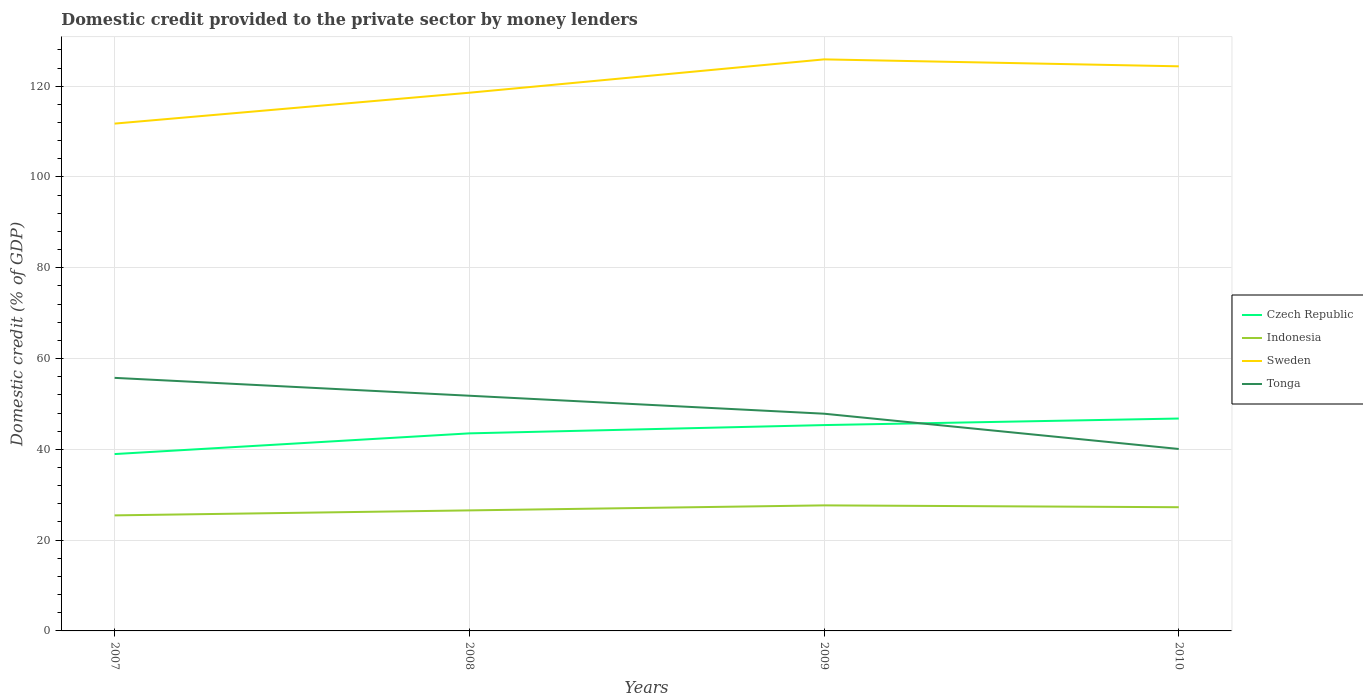How many different coloured lines are there?
Make the answer very short. 4. Does the line corresponding to Indonesia intersect with the line corresponding to Tonga?
Make the answer very short. No. Is the number of lines equal to the number of legend labels?
Keep it short and to the point. Yes. Across all years, what is the maximum domestic credit provided to the private sector by money lenders in Indonesia?
Your answer should be compact. 25.46. In which year was the domestic credit provided to the private sector by money lenders in Indonesia maximum?
Your answer should be very brief. 2007. What is the total domestic credit provided to the private sector by money lenders in Czech Republic in the graph?
Offer a very short reply. -6.39. What is the difference between the highest and the second highest domestic credit provided to the private sector by money lenders in Tonga?
Your response must be concise. 15.67. Is the domestic credit provided to the private sector by money lenders in Tonga strictly greater than the domestic credit provided to the private sector by money lenders in Sweden over the years?
Offer a very short reply. Yes. Where does the legend appear in the graph?
Make the answer very short. Center right. How are the legend labels stacked?
Provide a short and direct response. Vertical. What is the title of the graph?
Your answer should be very brief. Domestic credit provided to the private sector by money lenders. What is the label or title of the X-axis?
Offer a terse response. Years. What is the label or title of the Y-axis?
Offer a terse response. Domestic credit (% of GDP). What is the Domestic credit (% of GDP) of Czech Republic in 2007?
Offer a terse response. 38.96. What is the Domestic credit (% of GDP) in Indonesia in 2007?
Your answer should be compact. 25.46. What is the Domestic credit (% of GDP) of Sweden in 2007?
Provide a succinct answer. 111.76. What is the Domestic credit (% of GDP) of Tonga in 2007?
Provide a succinct answer. 55.75. What is the Domestic credit (% of GDP) of Czech Republic in 2008?
Ensure brevity in your answer.  43.52. What is the Domestic credit (% of GDP) of Indonesia in 2008?
Make the answer very short. 26.55. What is the Domestic credit (% of GDP) of Sweden in 2008?
Your response must be concise. 118.57. What is the Domestic credit (% of GDP) of Tonga in 2008?
Give a very brief answer. 51.81. What is the Domestic credit (% of GDP) in Czech Republic in 2009?
Make the answer very short. 45.35. What is the Domestic credit (% of GDP) of Indonesia in 2009?
Offer a very short reply. 27.66. What is the Domestic credit (% of GDP) in Sweden in 2009?
Provide a succinct answer. 125.91. What is the Domestic credit (% of GDP) in Tonga in 2009?
Your answer should be very brief. 47.85. What is the Domestic credit (% of GDP) in Czech Republic in 2010?
Your answer should be very brief. 46.79. What is the Domestic credit (% of GDP) of Indonesia in 2010?
Give a very brief answer. 27.25. What is the Domestic credit (% of GDP) in Sweden in 2010?
Keep it short and to the point. 124.38. What is the Domestic credit (% of GDP) in Tonga in 2010?
Keep it short and to the point. 40.08. Across all years, what is the maximum Domestic credit (% of GDP) of Czech Republic?
Your answer should be very brief. 46.79. Across all years, what is the maximum Domestic credit (% of GDP) in Indonesia?
Your answer should be compact. 27.66. Across all years, what is the maximum Domestic credit (% of GDP) of Sweden?
Give a very brief answer. 125.91. Across all years, what is the maximum Domestic credit (% of GDP) in Tonga?
Provide a short and direct response. 55.75. Across all years, what is the minimum Domestic credit (% of GDP) of Czech Republic?
Your response must be concise. 38.96. Across all years, what is the minimum Domestic credit (% of GDP) in Indonesia?
Your answer should be compact. 25.46. Across all years, what is the minimum Domestic credit (% of GDP) in Sweden?
Keep it short and to the point. 111.76. Across all years, what is the minimum Domestic credit (% of GDP) in Tonga?
Offer a terse response. 40.08. What is the total Domestic credit (% of GDP) in Czech Republic in the graph?
Give a very brief answer. 174.62. What is the total Domestic credit (% of GDP) in Indonesia in the graph?
Offer a terse response. 106.92. What is the total Domestic credit (% of GDP) in Sweden in the graph?
Ensure brevity in your answer.  480.62. What is the total Domestic credit (% of GDP) in Tonga in the graph?
Keep it short and to the point. 195.5. What is the difference between the Domestic credit (% of GDP) of Czech Republic in 2007 and that in 2008?
Give a very brief answer. -4.56. What is the difference between the Domestic credit (% of GDP) of Indonesia in 2007 and that in 2008?
Offer a very short reply. -1.1. What is the difference between the Domestic credit (% of GDP) in Sweden in 2007 and that in 2008?
Give a very brief answer. -6.81. What is the difference between the Domestic credit (% of GDP) in Tonga in 2007 and that in 2008?
Ensure brevity in your answer.  3.94. What is the difference between the Domestic credit (% of GDP) of Czech Republic in 2007 and that in 2009?
Offer a very short reply. -6.39. What is the difference between the Domestic credit (% of GDP) in Indonesia in 2007 and that in 2009?
Ensure brevity in your answer.  -2.2. What is the difference between the Domestic credit (% of GDP) in Sweden in 2007 and that in 2009?
Keep it short and to the point. -14.15. What is the difference between the Domestic credit (% of GDP) of Tonga in 2007 and that in 2009?
Ensure brevity in your answer.  7.9. What is the difference between the Domestic credit (% of GDP) of Czech Republic in 2007 and that in 2010?
Make the answer very short. -7.83. What is the difference between the Domestic credit (% of GDP) in Indonesia in 2007 and that in 2010?
Your response must be concise. -1.8. What is the difference between the Domestic credit (% of GDP) in Sweden in 2007 and that in 2010?
Your answer should be compact. -12.62. What is the difference between the Domestic credit (% of GDP) of Tonga in 2007 and that in 2010?
Make the answer very short. 15.67. What is the difference between the Domestic credit (% of GDP) of Czech Republic in 2008 and that in 2009?
Give a very brief answer. -1.83. What is the difference between the Domestic credit (% of GDP) of Indonesia in 2008 and that in 2009?
Provide a succinct answer. -1.11. What is the difference between the Domestic credit (% of GDP) in Sweden in 2008 and that in 2009?
Your answer should be very brief. -7.35. What is the difference between the Domestic credit (% of GDP) of Tonga in 2008 and that in 2009?
Your answer should be compact. 3.96. What is the difference between the Domestic credit (% of GDP) in Czech Republic in 2008 and that in 2010?
Make the answer very short. -3.27. What is the difference between the Domestic credit (% of GDP) in Indonesia in 2008 and that in 2010?
Your answer should be compact. -0.7. What is the difference between the Domestic credit (% of GDP) in Sweden in 2008 and that in 2010?
Ensure brevity in your answer.  -5.82. What is the difference between the Domestic credit (% of GDP) of Tonga in 2008 and that in 2010?
Your answer should be compact. 11.73. What is the difference between the Domestic credit (% of GDP) in Czech Republic in 2009 and that in 2010?
Make the answer very short. -1.44. What is the difference between the Domestic credit (% of GDP) of Indonesia in 2009 and that in 2010?
Keep it short and to the point. 0.41. What is the difference between the Domestic credit (% of GDP) of Sweden in 2009 and that in 2010?
Your answer should be compact. 1.53. What is the difference between the Domestic credit (% of GDP) in Tonga in 2009 and that in 2010?
Provide a succinct answer. 7.77. What is the difference between the Domestic credit (% of GDP) in Czech Republic in 2007 and the Domestic credit (% of GDP) in Indonesia in 2008?
Keep it short and to the point. 12.41. What is the difference between the Domestic credit (% of GDP) in Czech Republic in 2007 and the Domestic credit (% of GDP) in Sweden in 2008?
Offer a very short reply. -79.6. What is the difference between the Domestic credit (% of GDP) of Czech Republic in 2007 and the Domestic credit (% of GDP) of Tonga in 2008?
Your answer should be compact. -12.85. What is the difference between the Domestic credit (% of GDP) of Indonesia in 2007 and the Domestic credit (% of GDP) of Sweden in 2008?
Your response must be concise. -93.11. What is the difference between the Domestic credit (% of GDP) of Indonesia in 2007 and the Domestic credit (% of GDP) of Tonga in 2008?
Ensure brevity in your answer.  -26.36. What is the difference between the Domestic credit (% of GDP) of Sweden in 2007 and the Domestic credit (% of GDP) of Tonga in 2008?
Give a very brief answer. 59.95. What is the difference between the Domestic credit (% of GDP) of Czech Republic in 2007 and the Domestic credit (% of GDP) of Indonesia in 2009?
Give a very brief answer. 11.3. What is the difference between the Domestic credit (% of GDP) of Czech Republic in 2007 and the Domestic credit (% of GDP) of Sweden in 2009?
Provide a succinct answer. -86.95. What is the difference between the Domestic credit (% of GDP) in Czech Republic in 2007 and the Domestic credit (% of GDP) in Tonga in 2009?
Ensure brevity in your answer.  -8.89. What is the difference between the Domestic credit (% of GDP) in Indonesia in 2007 and the Domestic credit (% of GDP) in Sweden in 2009?
Your response must be concise. -100.46. What is the difference between the Domestic credit (% of GDP) of Indonesia in 2007 and the Domestic credit (% of GDP) of Tonga in 2009?
Ensure brevity in your answer.  -22.4. What is the difference between the Domestic credit (% of GDP) in Sweden in 2007 and the Domestic credit (% of GDP) in Tonga in 2009?
Provide a short and direct response. 63.91. What is the difference between the Domestic credit (% of GDP) of Czech Republic in 2007 and the Domestic credit (% of GDP) of Indonesia in 2010?
Provide a short and direct response. 11.71. What is the difference between the Domestic credit (% of GDP) of Czech Republic in 2007 and the Domestic credit (% of GDP) of Sweden in 2010?
Give a very brief answer. -85.42. What is the difference between the Domestic credit (% of GDP) in Czech Republic in 2007 and the Domestic credit (% of GDP) in Tonga in 2010?
Offer a very short reply. -1.12. What is the difference between the Domestic credit (% of GDP) in Indonesia in 2007 and the Domestic credit (% of GDP) in Sweden in 2010?
Your answer should be very brief. -98.93. What is the difference between the Domestic credit (% of GDP) of Indonesia in 2007 and the Domestic credit (% of GDP) of Tonga in 2010?
Ensure brevity in your answer.  -14.63. What is the difference between the Domestic credit (% of GDP) in Sweden in 2007 and the Domestic credit (% of GDP) in Tonga in 2010?
Your response must be concise. 71.68. What is the difference between the Domestic credit (% of GDP) of Czech Republic in 2008 and the Domestic credit (% of GDP) of Indonesia in 2009?
Your response must be concise. 15.86. What is the difference between the Domestic credit (% of GDP) of Czech Republic in 2008 and the Domestic credit (% of GDP) of Sweden in 2009?
Keep it short and to the point. -82.39. What is the difference between the Domestic credit (% of GDP) in Czech Republic in 2008 and the Domestic credit (% of GDP) in Tonga in 2009?
Ensure brevity in your answer.  -4.33. What is the difference between the Domestic credit (% of GDP) of Indonesia in 2008 and the Domestic credit (% of GDP) of Sweden in 2009?
Keep it short and to the point. -99.36. What is the difference between the Domestic credit (% of GDP) in Indonesia in 2008 and the Domestic credit (% of GDP) in Tonga in 2009?
Offer a very short reply. -21.3. What is the difference between the Domestic credit (% of GDP) in Sweden in 2008 and the Domestic credit (% of GDP) in Tonga in 2009?
Offer a very short reply. 70.71. What is the difference between the Domestic credit (% of GDP) in Czech Republic in 2008 and the Domestic credit (% of GDP) in Indonesia in 2010?
Make the answer very short. 16.27. What is the difference between the Domestic credit (% of GDP) of Czech Republic in 2008 and the Domestic credit (% of GDP) of Sweden in 2010?
Your answer should be very brief. -80.86. What is the difference between the Domestic credit (% of GDP) in Czech Republic in 2008 and the Domestic credit (% of GDP) in Tonga in 2010?
Make the answer very short. 3.44. What is the difference between the Domestic credit (% of GDP) of Indonesia in 2008 and the Domestic credit (% of GDP) of Sweden in 2010?
Make the answer very short. -97.83. What is the difference between the Domestic credit (% of GDP) in Indonesia in 2008 and the Domestic credit (% of GDP) in Tonga in 2010?
Offer a terse response. -13.53. What is the difference between the Domestic credit (% of GDP) in Sweden in 2008 and the Domestic credit (% of GDP) in Tonga in 2010?
Provide a succinct answer. 78.48. What is the difference between the Domestic credit (% of GDP) of Czech Republic in 2009 and the Domestic credit (% of GDP) of Indonesia in 2010?
Your response must be concise. 18.1. What is the difference between the Domestic credit (% of GDP) in Czech Republic in 2009 and the Domestic credit (% of GDP) in Sweden in 2010?
Keep it short and to the point. -79.03. What is the difference between the Domestic credit (% of GDP) in Czech Republic in 2009 and the Domestic credit (% of GDP) in Tonga in 2010?
Provide a short and direct response. 5.27. What is the difference between the Domestic credit (% of GDP) in Indonesia in 2009 and the Domestic credit (% of GDP) in Sweden in 2010?
Make the answer very short. -96.73. What is the difference between the Domestic credit (% of GDP) of Indonesia in 2009 and the Domestic credit (% of GDP) of Tonga in 2010?
Offer a terse response. -12.42. What is the difference between the Domestic credit (% of GDP) of Sweden in 2009 and the Domestic credit (% of GDP) of Tonga in 2010?
Offer a terse response. 85.83. What is the average Domestic credit (% of GDP) in Czech Republic per year?
Offer a very short reply. 43.66. What is the average Domestic credit (% of GDP) in Indonesia per year?
Ensure brevity in your answer.  26.73. What is the average Domestic credit (% of GDP) of Sweden per year?
Make the answer very short. 120.16. What is the average Domestic credit (% of GDP) in Tonga per year?
Ensure brevity in your answer.  48.87. In the year 2007, what is the difference between the Domestic credit (% of GDP) in Czech Republic and Domestic credit (% of GDP) in Indonesia?
Keep it short and to the point. 13.51. In the year 2007, what is the difference between the Domestic credit (% of GDP) in Czech Republic and Domestic credit (% of GDP) in Sweden?
Ensure brevity in your answer.  -72.8. In the year 2007, what is the difference between the Domestic credit (% of GDP) of Czech Republic and Domestic credit (% of GDP) of Tonga?
Your response must be concise. -16.79. In the year 2007, what is the difference between the Domestic credit (% of GDP) of Indonesia and Domestic credit (% of GDP) of Sweden?
Give a very brief answer. -86.31. In the year 2007, what is the difference between the Domestic credit (% of GDP) of Indonesia and Domestic credit (% of GDP) of Tonga?
Your response must be concise. -30.29. In the year 2007, what is the difference between the Domestic credit (% of GDP) in Sweden and Domestic credit (% of GDP) in Tonga?
Keep it short and to the point. 56.01. In the year 2008, what is the difference between the Domestic credit (% of GDP) of Czech Republic and Domestic credit (% of GDP) of Indonesia?
Give a very brief answer. 16.97. In the year 2008, what is the difference between the Domestic credit (% of GDP) of Czech Republic and Domestic credit (% of GDP) of Sweden?
Give a very brief answer. -75.04. In the year 2008, what is the difference between the Domestic credit (% of GDP) of Czech Republic and Domestic credit (% of GDP) of Tonga?
Ensure brevity in your answer.  -8.29. In the year 2008, what is the difference between the Domestic credit (% of GDP) of Indonesia and Domestic credit (% of GDP) of Sweden?
Offer a terse response. -92.01. In the year 2008, what is the difference between the Domestic credit (% of GDP) in Indonesia and Domestic credit (% of GDP) in Tonga?
Provide a short and direct response. -25.26. In the year 2008, what is the difference between the Domestic credit (% of GDP) in Sweden and Domestic credit (% of GDP) in Tonga?
Your response must be concise. 66.75. In the year 2009, what is the difference between the Domestic credit (% of GDP) in Czech Republic and Domestic credit (% of GDP) in Indonesia?
Your answer should be compact. 17.69. In the year 2009, what is the difference between the Domestic credit (% of GDP) in Czech Republic and Domestic credit (% of GDP) in Sweden?
Give a very brief answer. -80.56. In the year 2009, what is the difference between the Domestic credit (% of GDP) in Czech Republic and Domestic credit (% of GDP) in Tonga?
Make the answer very short. -2.5. In the year 2009, what is the difference between the Domestic credit (% of GDP) in Indonesia and Domestic credit (% of GDP) in Sweden?
Ensure brevity in your answer.  -98.25. In the year 2009, what is the difference between the Domestic credit (% of GDP) of Indonesia and Domestic credit (% of GDP) of Tonga?
Offer a terse response. -20.19. In the year 2009, what is the difference between the Domestic credit (% of GDP) in Sweden and Domestic credit (% of GDP) in Tonga?
Ensure brevity in your answer.  78.06. In the year 2010, what is the difference between the Domestic credit (% of GDP) of Czech Republic and Domestic credit (% of GDP) of Indonesia?
Keep it short and to the point. 19.54. In the year 2010, what is the difference between the Domestic credit (% of GDP) in Czech Republic and Domestic credit (% of GDP) in Sweden?
Give a very brief answer. -77.59. In the year 2010, what is the difference between the Domestic credit (% of GDP) of Czech Republic and Domestic credit (% of GDP) of Tonga?
Ensure brevity in your answer.  6.71. In the year 2010, what is the difference between the Domestic credit (% of GDP) in Indonesia and Domestic credit (% of GDP) in Sweden?
Provide a short and direct response. -97.13. In the year 2010, what is the difference between the Domestic credit (% of GDP) in Indonesia and Domestic credit (% of GDP) in Tonga?
Provide a short and direct response. -12.83. In the year 2010, what is the difference between the Domestic credit (% of GDP) in Sweden and Domestic credit (% of GDP) in Tonga?
Offer a very short reply. 84.3. What is the ratio of the Domestic credit (% of GDP) of Czech Republic in 2007 to that in 2008?
Keep it short and to the point. 0.9. What is the ratio of the Domestic credit (% of GDP) of Indonesia in 2007 to that in 2008?
Offer a terse response. 0.96. What is the ratio of the Domestic credit (% of GDP) in Sweden in 2007 to that in 2008?
Your answer should be compact. 0.94. What is the ratio of the Domestic credit (% of GDP) in Tonga in 2007 to that in 2008?
Make the answer very short. 1.08. What is the ratio of the Domestic credit (% of GDP) in Czech Republic in 2007 to that in 2009?
Your answer should be very brief. 0.86. What is the ratio of the Domestic credit (% of GDP) in Indonesia in 2007 to that in 2009?
Provide a short and direct response. 0.92. What is the ratio of the Domestic credit (% of GDP) of Sweden in 2007 to that in 2009?
Offer a very short reply. 0.89. What is the ratio of the Domestic credit (% of GDP) in Tonga in 2007 to that in 2009?
Keep it short and to the point. 1.17. What is the ratio of the Domestic credit (% of GDP) in Czech Republic in 2007 to that in 2010?
Make the answer very short. 0.83. What is the ratio of the Domestic credit (% of GDP) of Indonesia in 2007 to that in 2010?
Your response must be concise. 0.93. What is the ratio of the Domestic credit (% of GDP) in Sweden in 2007 to that in 2010?
Ensure brevity in your answer.  0.9. What is the ratio of the Domestic credit (% of GDP) of Tonga in 2007 to that in 2010?
Offer a terse response. 1.39. What is the ratio of the Domestic credit (% of GDP) of Czech Republic in 2008 to that in 2009?
Keep it short and to the point. 0.96. What is the ratio of the Domestic credit (% of GDP) of Indonesia in 2008 to that in 2009?
Offer a very short reply. 0.96. What is the ratio of the Domestic credit (% of GDP) in Sweden in 2008 to that in 2009?
Ensure brevity in your answer.  0.94. What is the ratio of the Domestic credit (% of GDP) of Tonga in 2008 to that in 2009?
Offer a terse response. 1.08. What is the ratio of the Domestic credit (% of GDP) in Czech Republic in 2008 to that in 2010?
Offer a very short reply. 0.93. What is the ratio of the Domestic credit (% of GDP) of Indonesia in 2008 to that in 2010?
Your response must be concise. 0.97. What is the ratio of the Domestic credit (% of GDP) in Sweden in 2008 to that in 2010?
Make the answer very short. 0.95. What is the ratio of the Domestic credit (% of GDP) in Tonga in 2008 to that in 2010?
Offer a terse response. 1.29. What is the ratio of the Domestic credit (% of GDP) of Czech Republic in 2009 to that in 2010?
Ensure brevity in your answer.  0.97. What is the ratio of the Domestic credit (% of GDP) of Indonesia in 2009 to that in 2010?
Provide a short and direct response. 1.01. What is the ratio of the Domestic credit (% of GDP) in Sweden in 2009 to that in 2010?
Give a very brief answer. 1.01. What is the ratio of the Domestic credit (% of GDP) of Tonga in 2009 to that in 2010?
Keep it short and to the point. 1.19. What is the difference between the highest and the second highest Domestic credit (% of GDP) in Czech Republic?
Ensure brevity in your answer.  1.44. What is the difference between the highest and the second highest Domestic credit (% of GDP) in Indonesia?
Offer a terse response. 0.41. What is the difference between the highest and the second highest Domestic credit (% of GDP) in Sweden?
Keep it short and to the point. 1.53. What is the difference between the highest and the second highest Domestic credit (% of GDP) of Tonga?
Your answer should be very brief. 3.94. What is the difference between the highest and the lowest Domestic credit (% of GDP) of Czech Republic?
Give a very brief answer. 7.83. What is the difference between the highest and the lowest Domestic credit (% of GDP) of Indonesia?
Provide a short and direct response. 2.2. What is the difference between the highest and the lowest Domestic credit (% of GDP) in Sweden?
Offer a very short reply. 14.15. What is the difference between the highest and the lowest Domestic credit (% of GDP) in Tonga?
Your answer should be compact. 15.67. 